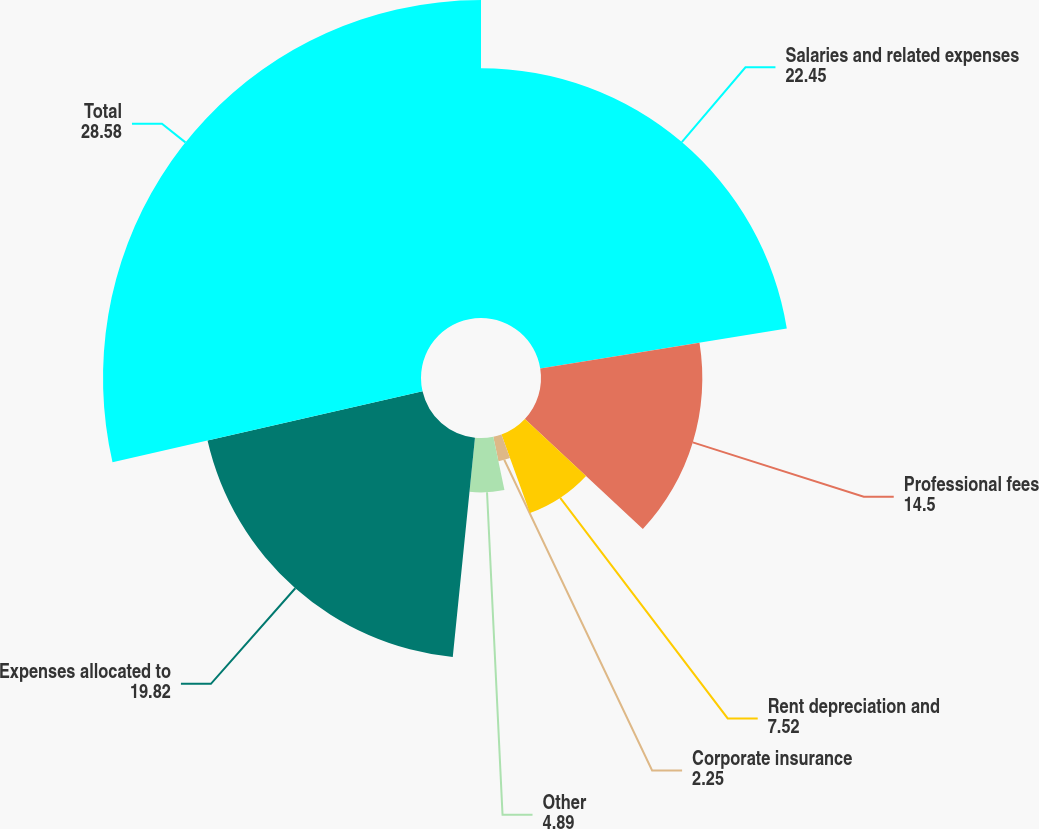Convert chart. <chart><loc_0><loc_0><loc_500><loc_500><pie_chart><fcel>Salaries and related expenses<fcel>Professional fees<fcel>Rent depreciation and<fcel>Corporate insurance<fcel>Other<fcel>Expenses allocated to<fcel>Total<nl><fcel>22.45%<fcel>14.5%<fcel>7.52%<fcel>2.25%<fcel>4.89%<fcel>19.82%<fcel>28.58%<nl></chart> 